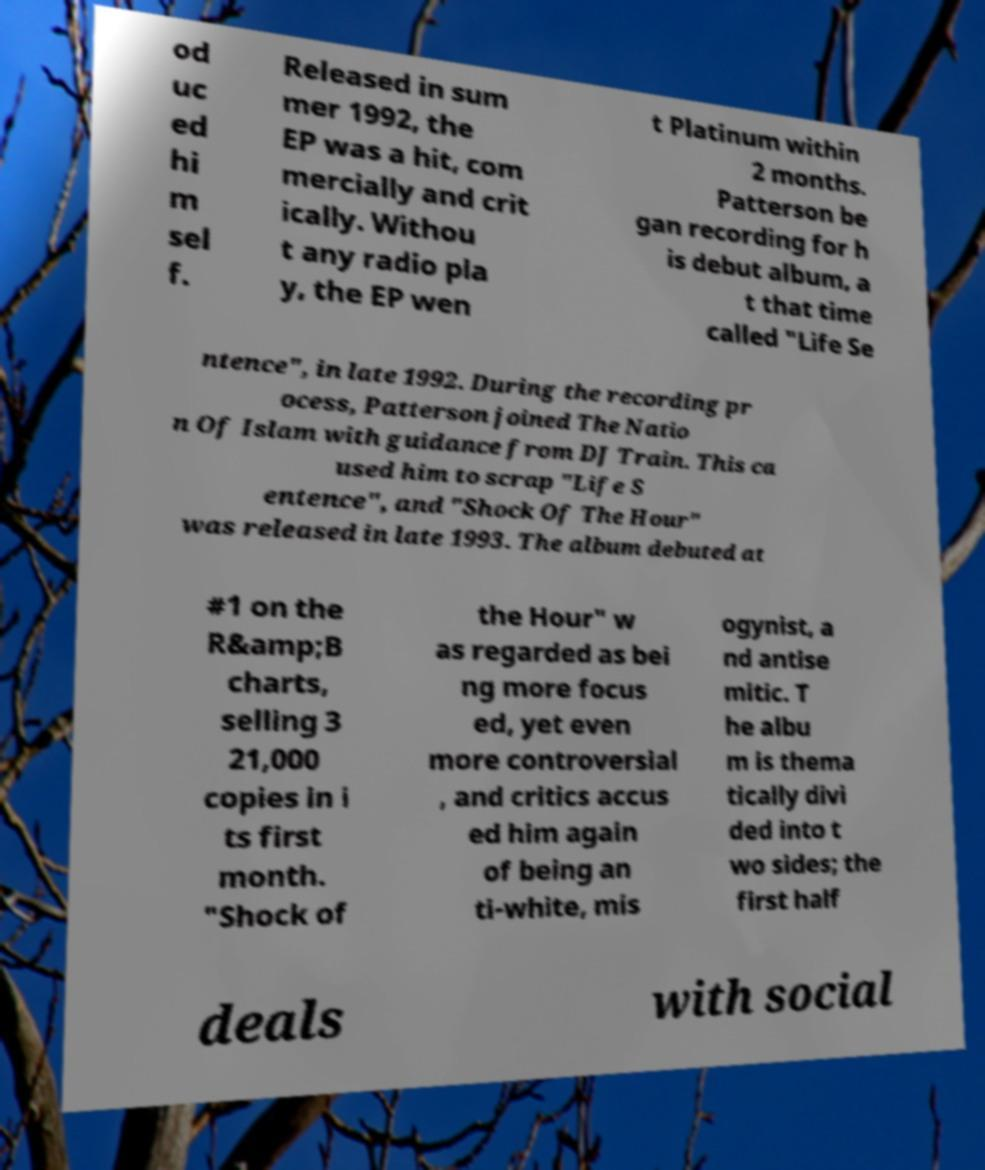Could you assist in decoding the text presented in this image and type it out clearly? od uc ed hi m sel f. Released in sum mer 1992, the EP was a hit, com mercially and crit ically. Withou t any radio pla y, the EP wen t Platinum within 2 months. Patterson be gan recording for h is debut album, a t that time called "Life Se ntence", in late 1992. During the recording pr ocess, Patterson joined The Natio n Of Islam with guidance from DJ Train. This ca used him to scrap "Life S entence", and "Shock Of The Hour" was released in late 1993. The album debuted at #1 on the R&amp;B charts, selling 3 21,000 copies in i ts first month. "Shock of the Hour" w as regarded as bei ng more focus ed, yet even more controversial , and critics accus ed him again of being an ti-white, mis ogynist, a nd antise mitic. T he albu m is thema tically divi ded into t wo sides; the first half deals with social 